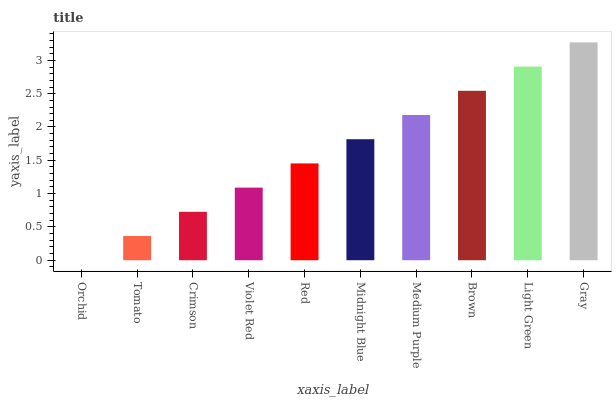Is Tomato the minimum?
Answer yes or no. No. Is Tomato the maximum?
Answer yes or no. No. Is Tomato greater than Orchid?
Answer yes or no. Yes. Is Orchid less than Tomato?
Answer yes or no. Yes. Is Orchid greater than Tomato?
Answer yes or no. No. Is Tomato less than Orchid?
Answer yes or no. No. Is Midnight Blue the high median?
Answer yes or no. Yes. Is Red the low median?
Answer yes or no. Yes. Is Crimson the high median?
Answer yes or no. No. Is Crimson the low median?
Answer yes or no. No. 